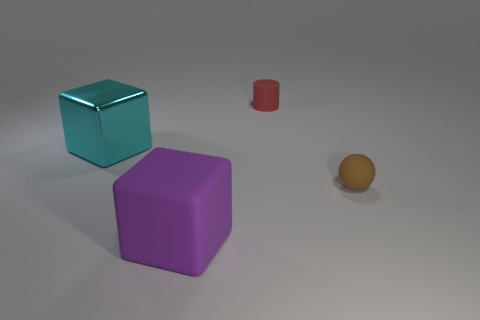Subtract 1 blocks. How many blocks are left? 1 Subtract 0 blue spheres. How many objects are left? 4 Subtract all spheres. How many objects are left? 3 Subtract all purple cylinders. Subtract all red cubes. How many cylinders are left? 1 Subtract all brown balls. How many green cylinders are left? 0 Subtract all large gray rubber blocks. Subtract all red matte cylinders. How many objects are left? 3 Add 2 matte cylinders. How many matte cylinders are left? 3 Add 2 red matte things. How many red matte things exist? 3 Add 3 small cyan balls. How many objects exist? 7 